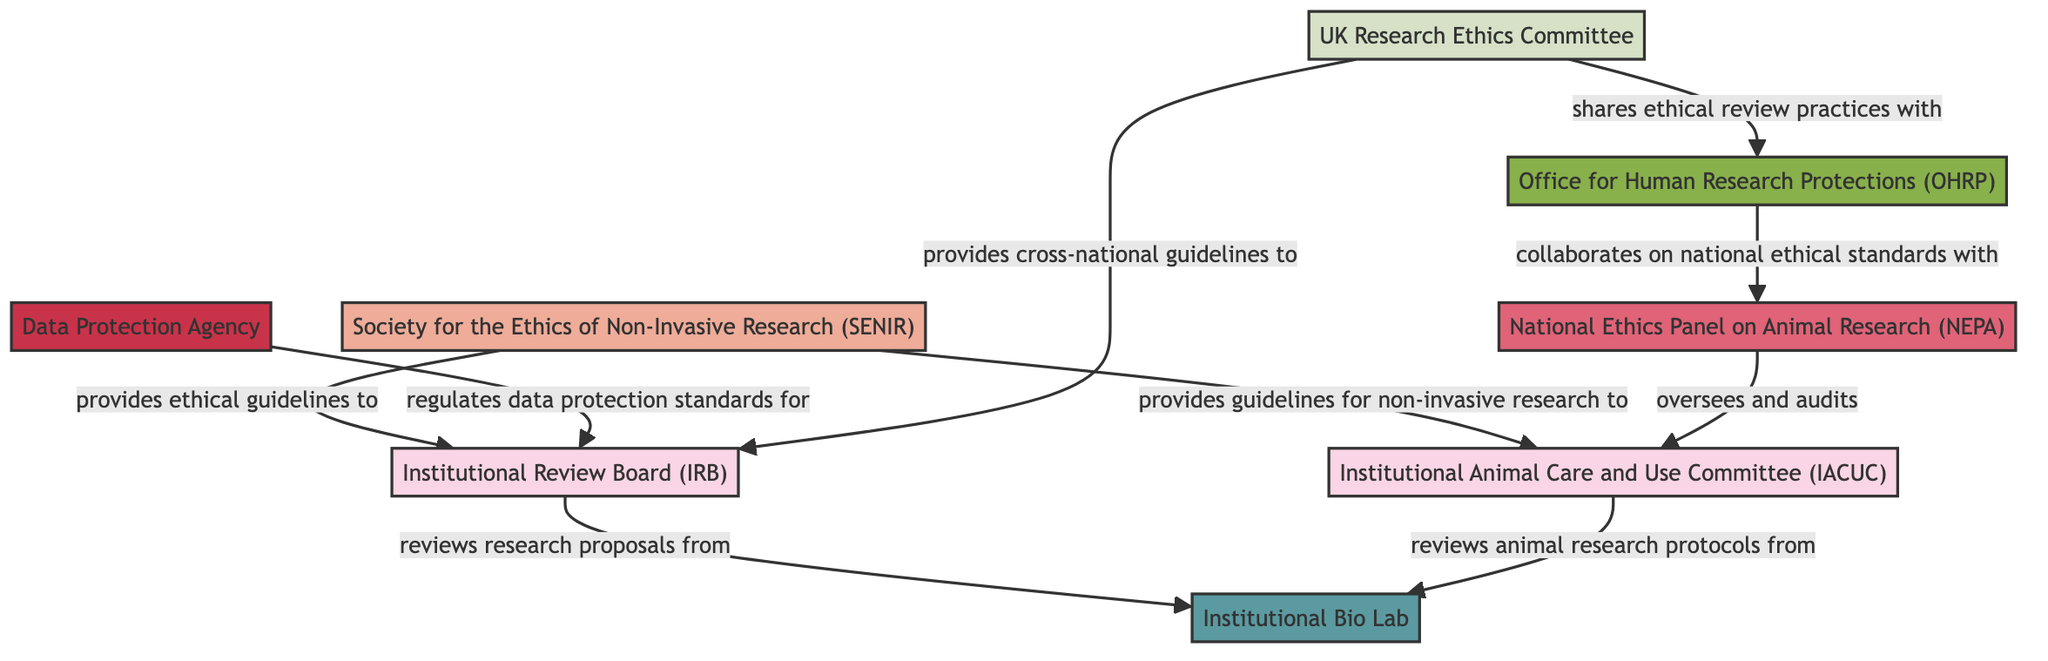What is the total number of nodes in the diagram? By counting each unique node listed in the data, we can determine there are eight nodes: Institutional Review Board, Institutional Animal Care and Use Committee, Society for the Ethics of Non-Invasive Research, National Ethics Panel on Animal Research, Data Protection Agency, Institutional Bio Lab, UK Research Ethics Committee, and Office for Human Research Protections.
Answer: 8 What type of body is the Society for the Ethics of Non-Invasive Research? According to the node classification in the diagram, the Society for the Ethics of Non-Invasive Research is categorized as a professional society.
Answer: Professional Society Which entity provides ethical guidelines to the Institutional Review Board? Referring to the relationship in the diagram, it is clear that the Society for the Ethics of Non-Invasive Research provides ethical guidelines to the Institutional Review Board.
Answer: Society for the Ethics of Non-Invasive Research How many relationships involve the Institutional Bio Lab? The diagram shows two relationships connecting the Institutional Bio Lab; one with the Institutional Review Board and one with the Institutional Animal Care and Use Committee, indicating that both review proposals and protocols from the lab.
Answer: 2 What type of entity is the Office for Human Research Protections? By examining the node classification in the diagram, it is indicated that the Office for Human Research Protections is categorized as a government agency.
Answer: Government Agency Which entity oversees and audits the Institutional Animal Care and Use Committee? The data specifies that the National Ethics Panel on Animal Research oversees and audits the Institutional Animal Care and Use Committee. By looking at the directional arrows in the diagram, this relationship is clearly depicted.
Answer: National Ethics Panel on Animal Research How many edges are there that involve guidelines or standards sharing? Counting the definitions and edges in the diagram, there are three edges that involve guidelines or standards sharing: from the Society for the Ethics of Non-Invasive Research to the IRB and IACUC, and from the UK Research Ethics Committee to the IRB.
Answer: 3 Which review body receives ethical review practices from the UK Research Ethics Committee? The directed edge shows that the UK Research Ethics Committee shares ethical review practices with the Office for Human Research Protections, establishing a clear relationship between these two nodes.
Answer: Office for Human Research Protections What is the relationship between the Data Protection Agency and the Institutional Review Board? The diagram indicates that the Data Protection Agency regulates data protection standards for the Institutional Review Board, forming a clear functional relationship between them.
Answer: Regulates data protection standards for 